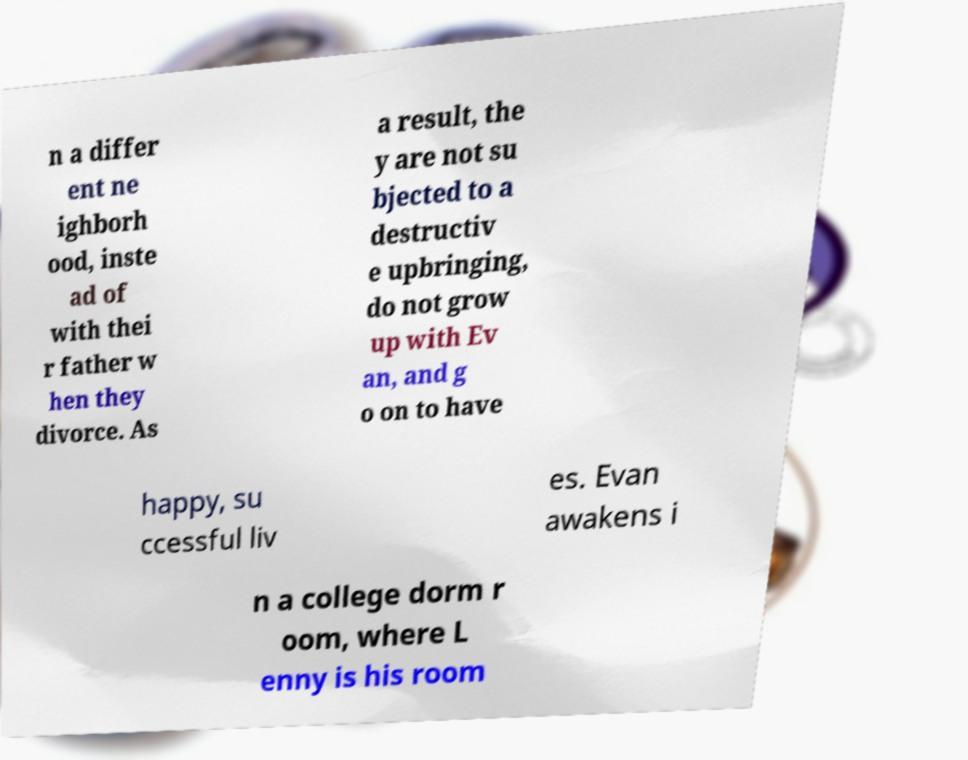Can you accurately transcribe the text from the provided image for me? n a differ ent ne ighborh ood, inste ad of with thei r father w hen they divorce. As a result, the y are not su bjected to a destructiv e upbringing, do not grow up with Ev an, and g o on to have happy, su ccessful liv es. Evan awakens i n a college dorm r oom, where L enny is his room 